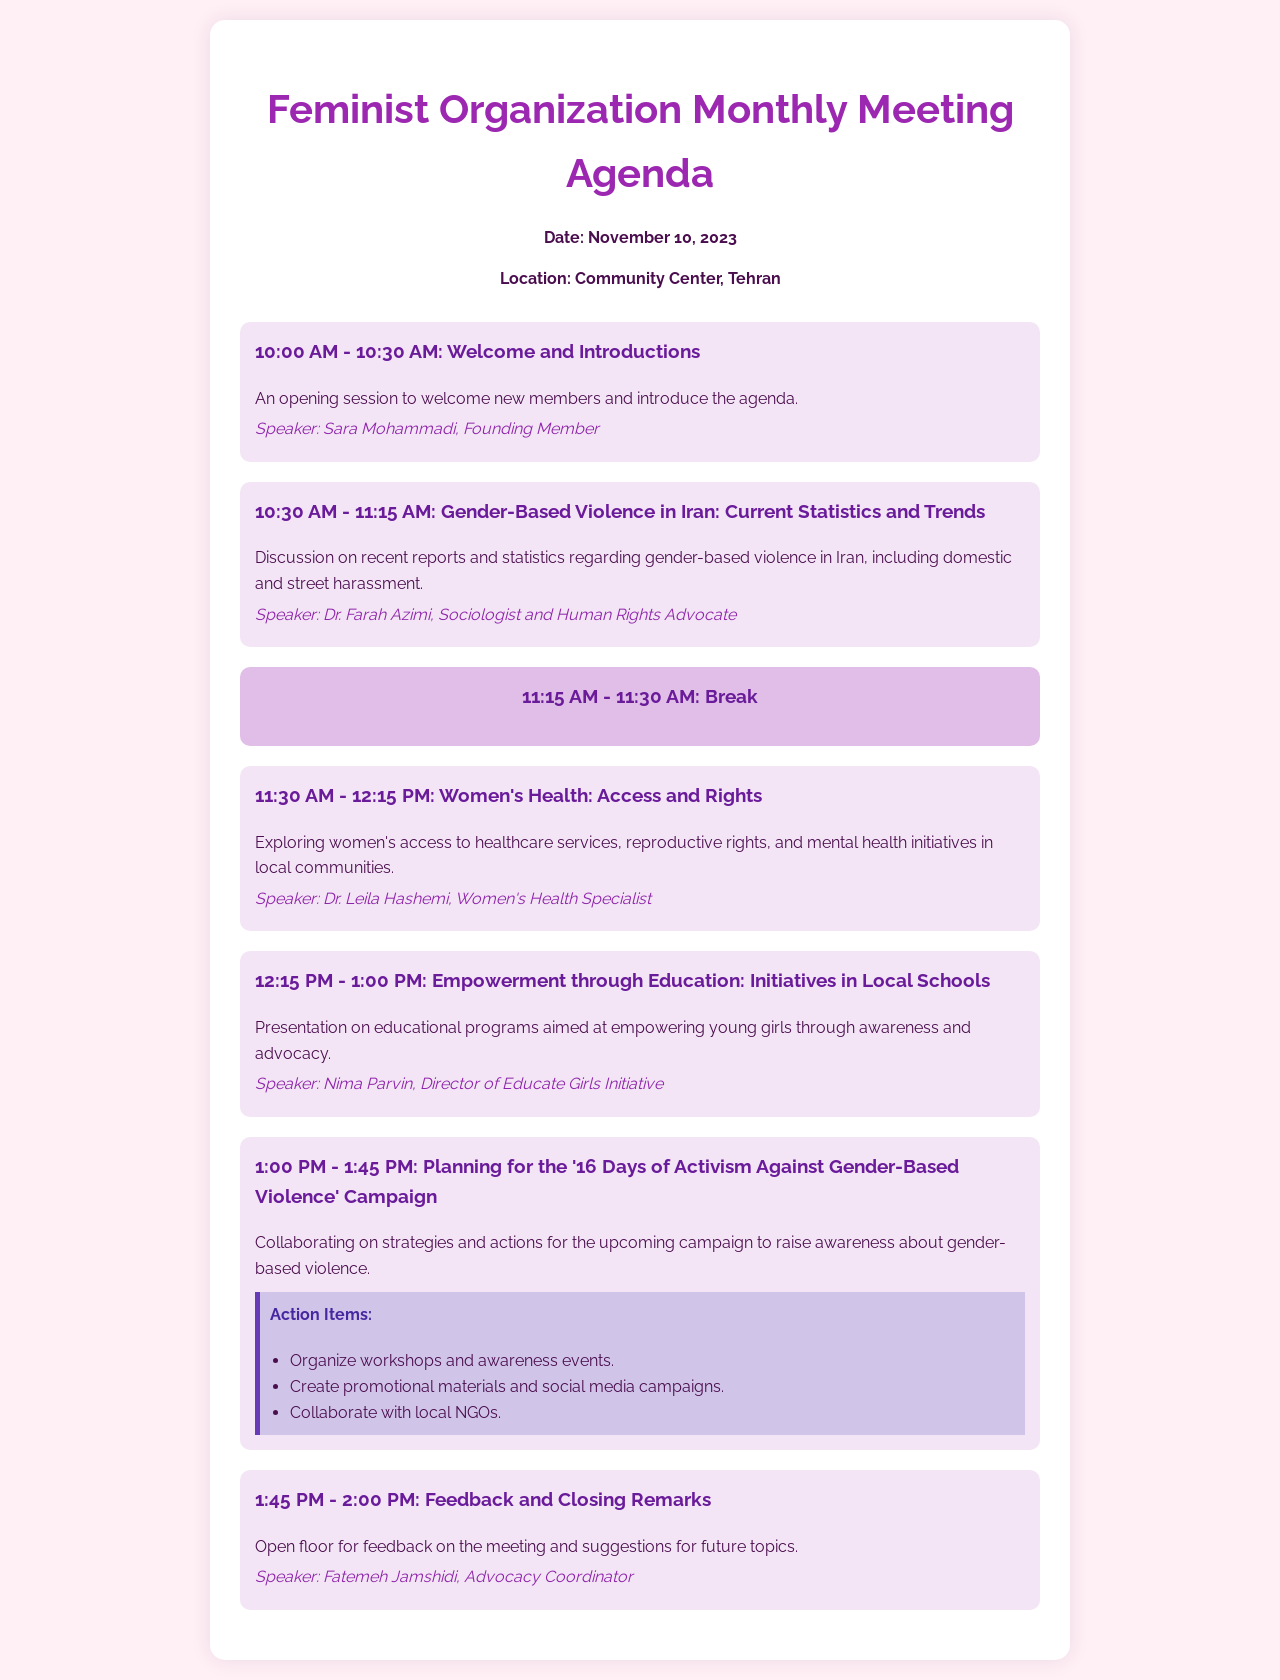What is the date of the meeting? The date of the meeting is stated clearly in the document.
Answer: November 10, 2023 Who is the speaker for the "Welcome and Introductions" session? The speaker's name is provided in the agenda item for welcome and introductions.
Answer: Sara Mohammadi What topic is discussed between 10:30 AM and 11:15 AM? The specific topic discussed during this time is provided in the agenda.
Answer: Gender-Based Violence in Iran: Current Statistics and Trends How long is the break scheduled for? The duration of the break is mentioned directly in the agenda section.
Answer: 15 minutes What will be planned during the "Planning for the '16 Days of Activism Against Gender-Based Violence' Campaign"? This is an important action item discussed in the agenda, indicating what will occur during the session.
Answer: Collaborating on strategies and actions Who is the speaker for the session on women's health? The document specifies who will lead the discussion on women's health.
Answer: Dr. Leila Hashemi What is the location of the meeting? The meeting location is provided in the meeting information section.
Answer: Community Center, Tehran What time does the meeting start? The starting time of the meeting is indicated in the agenda.
Answer: 10:00 AM 